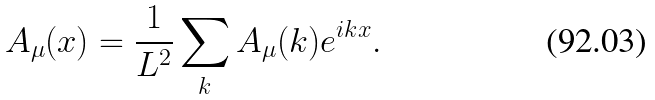<formula> <loc_0><loc_0><loc_500><loc_500>A _ { \mu } ( x ) = \frac { 1 } { L ^ { 2 } } \sum _ { k } A _ { \mu } ( k ) e ^ { i k x } .</formula> 